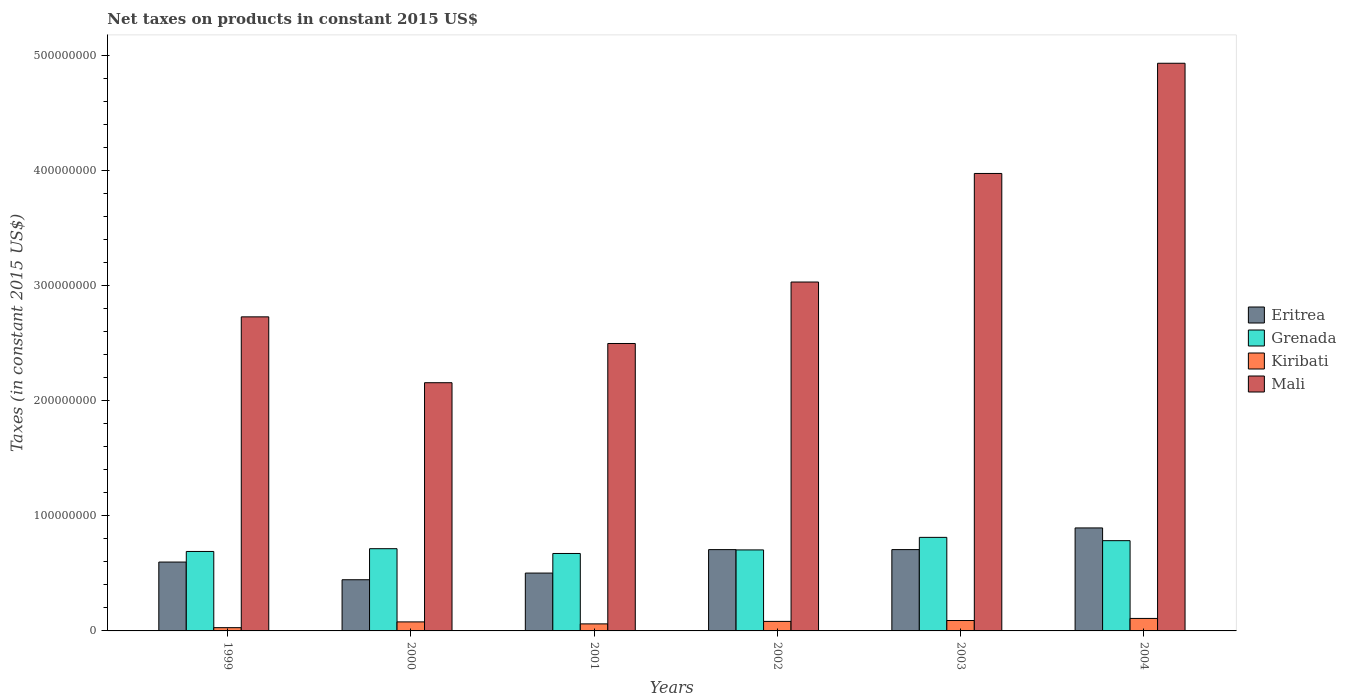How many groups of bars are there?
Provide a short and direct response. 6. How many bars are there on the 4th tick from the left?
Provide a succinct answer. 4. In how many cases, is the number of bars for a given year not equal to the number of legend labels?
Offer a very short reply. 0. What is the net taxes on products in Eritrea in 1999?
Offer a very short reply. 5.98e+07. Across all years, what is the maximum net taxes on products in Grenada?
Provide a short and direct response. 8.12e+07. Across all years, what is the minimum net taxes on products in Grenada?
Keep it short and to the point. 6.73e+07. In which year was the net taxes on products in Eritrea maximum?
Ensure brevity in your answer.  2004. What is the total net taxes on products in Grenada in the graph?
Keep it short and to the point. 4.38e+08. What is the difference between the net taxes on products in Mali in 2000 and that in 2003?
Ensure brevity in your answer.  -1.82e+08. What is the difference between the net taxes on products in Grenada in 2003 and the net taxes on products in Mali in 1999?
Provide a succinct answer. -1.91e+08. What is the average net taxes on products in Mali per year?
Keep it short and to the point. 3.22e+08. In the year 2000, what is the difference between the net taxes on products in Kiribati and net taxes on products in Mali?
Offer a very short reply. -2.08e+08. In how many years, is the net taxes on products in Mali greater than 100000000 US$?
Make the answer very short. 6. What is the ratio of the net taxes on products in Grenada in 2002 to that in 2003?
Your answer should be compact. 0.87. Is the difference between the net taxes on products in Kiribati in 2000 and 2004 greater than the difference between the net taxes on products in Mali in 2000 and 2004?
Your response must be concise. Yes. What is the difference between the highest and the second highest net taxes on products in Eritrea?
Offer a very short reply. 1.88e+07. What is the difference between the highest and the lowest net taxes on products in Eritrea?
Keep it short and to the point. 4.50e+07. Is it the case that in every year, the sum of the net taxes on products in Kiribati and net taxes on products in Mali is greater than the sum of net taxes on products in Grenada and net taxes on products in Eritrea?
Make the answer very short. No. What does the 1st bar from the left in 2001 represents?
Keep it short and to the point. Eritrea. What does the 1st bar from the right in 2001 represents?
Ensure brevity in your answer.  Mali. How many bars are there?
Make the answer very short. 24. Are all the bars in the graph horizontal?
Offer a terse response. No. How many years are there in the graph?
Your answer should be very brief. 6. Where does the legend appear in the graph?
Your response must be concise. Center right. What is the title of the graph?
Keep it short and to the point. Net taxes on products in constant 2015 US$. What is the label or title of the X-axis?
Keep it short and to the point. Years. What is the label or title of the Y-axis?
Give a very brief answer. Taxes (in constant 2015 US$). What is the Taxes (in constant 2015 US$) in Eritrea in 1999?
Ensure brevity in your answer.  5.98e+07. What is the Taxes (in constant 2015 US$) in Grenada in 1999?
Keep it short and to the point. 6.90e+07. What is the Taxes (in constant 2015 US$) in Kiribati in 1999?
Offer a terse response. 2.83e+06. What is the Taxes (in constant 2015 US$) in Mali in 1999?
Your answer should be compact. 2.73e+08. What is the Taxes (in constant 2015 US$) in Eritrea in 2000?
Ensure brevity in your answer.  4.44e+07. What is the Taxes (in constant 2015 US$) in Grenada in 2000?
Make the answer very short. 7.14e+07. What is the Taxes (in constant 2015 US$) in Kiribati in 2000?
Your answer should be very brief. 7.83e+06. What is the Taxes (in constant 2015 US$) in Mali in 2000?
Your answer should be very brief. 2.16e+08. What is the Taxes (in constant 2015 US$) of Eritrea in 2001?
Offer a very short reply. 5.02e+07. What is the Taxes (in constant 2015 US$) of Grenada in 2001?
Make the answer very short. 6.73e+07. What is the Taxes (in constant 2015 US$) in Kiribati in 2001?
Ensure brevity in your answer.  6.11e+06. What is the Taxes (in constant 2015 US$) in Mali in 2001?
Give a very brief answer. 2.50e+08. What is the Taxes (in constant 2015 US$) in Eritrea in 2002?
Your answer should be very brief. 7.06e+07. What is the Taxes (in constant 2015 US$) in Grenada in 2002?
Your answer should be very brief. 7.03e+07. What is the Taxes (in constant 2015 US$) in Kiribati in 2002?
Give a very brief answer. 8.26e+06. What is the Taxes (in constant 2015 US$) of Mali in 2002?
Your answer should be compact. 3.03e+08. What is the Taxes (in constant 2015 US$) of Eritrea in 2003?
Your response must be concise. 7.06e+07. What is the Taxes (in constant 2015 US$) in Grenada in 2003?
Give a very brief answer. 8.12e+07. What is the Taxes (in constant 2015 US$) in Kiribati in 2003?
Provide a short and direct response. 9.03e+06. What is the Taxes (in constant 2015 US$) of Mali in 2003?
Ensure brevity in your answer.  3.97e+08. What is the Taxes (in constant 2015 US$) of Eritrea in 2004?
Offer a terse response. 8.94e+07. What is the Taxes (in constant 2015 US$) of Grenada in 2004?
Offer a terse response. 7.84e+07. What is the Taxes (in constant 2015 US$) of Kiribati in 2004?
Provide a short and direct response. 1.08e+07. What is the Taxes (in constant 2015 US$) of Mali in 2004?
Give a very brief answer. 4.93e+08. Across all years, what is the maximum Taxes (in constant 2015 US$) of Eritrea?
Provide a succinct answer. 8.94e+07. Across all years, what is the maximum Taxes (in constant 2015 US$) in Grenada?
Ensure brevity in your answer.  8.12e+07. Across all years, what is the maximum Taxes (in constant 2015 US$) in Kiribati?
Your response must be concise. 1.08e+07. Across all years, what is the maximum Taxes (in constant 2015 US$) in Mali?
Your answer should be very brief. 4.93e+08. Across all years, what is the minimum Taxes (in constant 2015 US$) of Eritrea?
Offer a terse response. 4.44e+07. Across all years, what is the minimum Taxes (in constant 2015 US$) of Grenada?
Your answer should be very brief. 6.73e+07. Across all years, what is the minimum Taxes (in constant 2015 US$) in Kiribati?
Your answer should be very brief. 2.83e+06. Across all years, what is the minimum Taxes (in constant 2015 US$) of Mali?
Give a very brief answer. 2.16e+08. What is the total Taxes (in constant 2015 US$) of Eritrea in the graph?
Your answer should be very brief. 3.85e+08. What is the total Taxes (in constant 2015 US$) of Grenada in the graph?
Offer a very short reply. 4.38e+08. What is the total Taxes (in constant 2015 US$) in Kiribati in the graph?
Ensure brevity in your answer.  4.49e+07. What is the total Taxes (in constant 2015 US$) in Mali in the graph?
Your answer should be compact. 1.93e+09. What is the difference between the Taxes (in constant 2015 US$) in Eritrea in 1999 and that in 2000?
Provide a short and direct response. 1.54e+07. What is the difference between the Taxes (in constant 2015 US$) in Grenada in 1999 and that in 2000?
Your answer should be compact. -2.40e+06. What is the difference between the Taxes (in constant 2015 US$) in Kiribati in 1999 and that in 2000?
Your answer should be compact. -5.00e+06. What is the difference between the Taxes (in constant 2015 US$) of Mali in 1999 and that in 2000?
Your answer should be compact. 5.72e+07. What is the difference between the Taxes (in constant 2015 US$) in Eritrea in 1999 and that in 2001?
Offer a terse response. 9.56e+06. What is the difference between the Taxes (in constant 2015 US$) of Grenada in 1999 and that in 2001?
Your answer should be compact. 1.75e+06. What is the difference between the Taxes (in constant 2015 US$) in Kiribati in 1999 and that in 2001?
Keep it short and to the point. -3.28e+06. What is the difference between the Taxes (in constant 2015 US$) of Mali in 1999 and that in 2001?
Your answer should be compact. 2.31e+07. What is the difference between the Taxes (in constant 2015 US$) of Eritrea in 1999 and that in 2002?
Give a very brief answer. -1.08e+07. What is the difference between the Taxes (in constant 2015 US$) in Grenada in 1999 and that in 2002?
Your answer should be very brief. -1.34e+06. What is the difference between the Taxes (in constant 2015 US$) of Kiribati in 1999 and that in 2002?
Provide a short and direct response. -5.44e+06. What is the difference between the Taxes (in constant 2015 US$) of Mali in 1999 and that in 2002?
Provide a short and direct response. -3.03e+07. What is the difference between the Taxes (in constant 2015 US$) of Eritrea in 1999 and that in 2003?
Your response must be concise. -1.08e+07. What is the difference between the Taxes (in constant 2015 US$) of Grenada in 1999 and that in 2003?
Provide a short and direct response. -1.22e+07. What is the difference between the Taxes (in constant 2015 US$) of Kiribati in 1999 and that in 2003?
Offer a very short reply. -6.21e+06. What is the difference between the Taxes (in constant 2015 US$) of Mali in 1999 and that in 2003?
Your answer should be very brief. -1.25e+08. What is the difference between the Taxes (in constant 2015 US$) in Eritrea in 1999 and that in 2004?
Your response must be concise. -2.96e+07. What is the difference between the Taxes (in constant 2015 US$) of Grenada in 1999 and that in 2004?
Provide a succinct answer. -9.37e+06. What is the difference between the Taxes (in constant 2015 US$) of Kiribati in 1999 and that in 2004?
Your response must be concise. -8.02e+06. What is the difference between the Taxes (in constant 2015 US$) in Mali in 1999 and that in 2004?
Your answer should be compact. -2.20e+08. What is the difference between the Taxes (in constant 2015 US$) of Eritrea in 2000 and that in 2001?
Offer a very short reply. -5.80e+06. What is the difference between the Taxes (in constant 2015 US$) in Grenada in 2000 and that in 2001?
Ensure brevity in your answer.  4.15e+06. What is the difference between the Taxes (in constant 2015 US$) in Kiribati in 2000 and that in 2001?
Provide a short and direct response. 1.73e+06. What is the difference between the Taxes (in constant 2015 US$) in Mali in 2000 and that in 2001?
Offer a terse response. -3.41e+07. What is the difference between the Taxes (in constant 2015 US$) of Eritrea in 2000 and that in 2002?
Keep it short and to the point. -2.62e+07. What is the difference between the Taxes (in constant 2015 US$) in Grenada in 2000 and that in 2002?
Provide a succinct answer. 1.06e+06. What is the difference between the Taxes (in constant 2015 US$) of Kiribati in 2000 and that in 2002?
Your answer should be very brief. -4.34e+05. What is the difference between the Taxes (in constant 2015 US$) in Mali in 2000 and that in 2002?
Offer a very short reply. -8.74e+07. What is the difference between the Taxes (in constant 2015 US$) in Eritrea in 2000 and that in 2003?
Make the answer very short. -2.62e+07. What is the difference between the Taxes (in constant 2015 US$) of Grenada in 2000 and that in 2003?
Make the answer very short. -9.83e+06. What is the difference between the Taxes (in constant 2015 US$) of Kiribati in 2000 and that in 2003?
Provide a succinct answer. -1.20e+06. What is the difference between the Taxes (in constant 2015 US$) in Mali in 2000 and that in 2003?
Keep it short and to the point. -1.82e+08. What is the difference between the Taxes (in constant 2015 US$) in Eritrea in 2000 and that in 2004?
Provide a succinct answer. -4.50e+07. What is the difference between the Taxes (in constant 2015 US$) in Grenada in 2000 and that in 2004?
Your answer should be very brief. -6.97e+06. What is the difference between the Taxes (in constant 2015 US$) in Kiribati in 2000 and that in 2004?
Provide a succinct answer. -3.01e+06. What is the difference between the Taxes (in constant 2015 US$) in Mali in 2000 and that in 2004?
Offer a terse response. -2.77e+08. What is the difference between the Taxes (in constant 2015 US$) in Eritrea in 2001 and that in 2002?
Offer a terse response. -2.04e+07. What is the difference between the Taxes (in constant 2015 US$) of Grenada in 2001 and that in 2002?
Your response must be concise. -3.10e+06. What is the difference between the Taxes (in constant 2015 US$) of Kiribati in 2001 and that in 2002?
Give a very brief answer. -2.16e+06. What is the difference between the Taxes (in constant 2015 US$) in Mali in 2001 and that in 2002?
Your response must be concise. -5.34e+07. What is the difference between the Taxes (in constant 2015 US$) of Eritrea in 2001 and that in 2003?
Ensure brevity in your answer.  -2.04e+07. What is the difference between the Taxes (in constant 2015 US$) of Grenada in 2001 and that in 2003?
Keep it short and to the point. -1.40e+07. What is the difference between the Taxes (in constant 2015 US$) of Kiribati in 2001 and that in 2003?
Your response must be concise. -2.93e+06. What is the difference between the Taxes (in constant 2015 US$) in Mali in 2001 and that in 2003?
Make the answer very short. -1.48e+08. What is the difference between the Taxes (in constant 2015 US$) in Eritrea in 2001 and that in 2004?
Your response must be concise. -3.92e+07. What is the difference between the Taxes (in constant 2015 US$) of Grenada in 2001 and that in 2004?
Make the answer very short. -1.11e+07. What is the difference between the Taxes (in constant 2015 US$) of Kiribati in 2001 and that in 2004?
Provide a short and direct response. -4.74e+06. What is the difference between the Taxes (in constant 2015 US$) in Mali in 2001 and that in 2004?
Provide a succinct answer. -2.43e+08. What is the difference between the Taxes (in constant 2015 US$) in Eritrea in 2002 and that in 2003?
Keep it short and to the point. -1.22e+04. What is the difference between the Taxes (in constant 2015 US$) of Grenada in 2002 and that in 2003?
Your answer should be very brief. -1.09e+07. What is the difference between the Taxes (in constant 2015 US$) in Kiribati in 2002 and that in 2003?
Ensure brevity in your answer.  -7.69e+05. What is the difference between the Taxes (in constant 2015 US$) of Mali in 2002 and that in 2003?
Your response must be concise. -9.43e+07. What is the difference between the Taxes (in constant 2015 US$) of Eritrea in 2002 and that in 2004?
Provide a succinct answer. -1.88e+07. What is the difference between the Taxes (in constant 2015 US$) in Grenada in 2002 and that in 2004?
Offer a terse response. -8.02e+06. What is the difference between the Taxes (in constant 2015 US$) of Kiribati in 2002 and that in 2004?
Your response must be concise. -2.58e+06. What is the difference between the Taxes (in constant 2015 US$) in Mali in 2002 and that in 2004?
Your response must be concise. -1.90e+08. What is the difference between the Taxes (in constant 2015 US$) in Eritrea in 2003 and that in 2004?
Your answer should be very brief. -1.88e+07. What is the difference between the Taxes (in constant 2015 US$) in Grenada in 2003 and that in 2004?
Offer a terse response. 2.86e+06. What is the difference between the Taxes (in constant 2015 US$) of Kiribati in 2003 and that in 2004?
Your answer should be compact. -1.81e+06. What is the difference between the Taxes (in constant 2015 US$) of Mali in 2003 and that in 2004?
Give a very brief answer. -9.57e+07. What is the difference between the Taxes (in constant 2015 US$) of Eritrea in 1999 and the Taxes (in constant 2015 US$) of Grenada in 2000?
Make the answer very short. -1.16e+07. What is the difference between the Taxes (in constant 2015 US$) in Eritrea in 1999 and the Taxes (in constant 2015 US$) in Kiribati in 2000?
Your response must be concise. 5.20e+07. What is the difference between the Taxes (in constant 2015 US$) in Eritrea in 1999 and the Taxes (in constant 2015 US$) in Mali in 2000?
Keep it short and to the point. -1.56e+08. What is the difference between the Taxes (in constant 2015 US$) in Grenada in 1999 and the Taxes (in constant 2015 US$) in Kiribati in 2000?
Give a very brief answer. 6.12e+07. What is the difference between the Taxes (in constant 2015 US$) of Grenada in 1999 and the Taxes (in constant 2015 US$) of Mali in 2000?
Your response must be concise. -1.47e+08. What is the difference between the Taxes (in constant 2015 US$) of Kiribati in 1999 and the Taxes (in constant 2015 US$) of Mali in 2000?
Your answer should be compact. -2.13e+08. What is the difference between the Taxes (in constant 2015 US$) in Eritrea in 1999 and the Taxes (in constant 2015 US$) in Grenada in 2001?
Offer a terse response. -7.45e+06. What is the difference between the Taxes (in constant 2015 US$) in Eritrea in 1999 and the Taxes (in constant 2015 US$) in Kiribati in 2001?
Ensure brevity in your answer.  5.37e+07. What is the difference between the Taxes (in constant 2015 US$) in Eritrea in 1999 and the Taxes (in constant 2015 US$) in Mali in 2001?
Your response must be concise. -1.90e+08. What is the difference between the Taxes (in constant 2015 US$) in Grenada in 1999 and the Taxes (in constant 2015 US$) in Kiribati in 2001?
Your answer should be very brief. 6.29e+07. What is the difference between the Taxes (in constant 2015 US$) in Grenada in 1999 and the Taxes (in constant 2015 US$) in Mali in 2001?
Your answer should be very brief. -1.81e+08. What is the difference between the Taxes (in constant 2015 US$) of Kiribati in 1999 and the Taxes (in constant 2015 US$) of Mali in 2001?
Keep it short and to the point. -2.47e+08. What is the difference between the Taxes (in constant 2015 US$) in Eritrea in 1999 and the Taxes (in constant 2015 US$) in Grenada in 2002?
Make the answer very short. -1.06e+07. What is the difference between the Taxes (in constant 2015 US$) of Eritrea in 1999 and the Taxes (in constant 2015 US$) of Kiribati in 2002?
Give a very brief answer. 5.15e+07. What is the difference between the Taxes (in constant 2015 US$) in Eritrea in 1999 and the Taxes (in constant 2015 US$) in Mali in 2002?
Offer a terse response. -2.43e+08. What is the difference between the Taxes (in constant 2015 US$) in Grenada in 1999 and the Taxes (in constant 2015 US$) in Kiribati in 2002?
Your answer should be compact. 6.07e+07. What is the difference between the Taxes (in constant 2015 US$) in Grenada in 1999 and the Taxes (in constant 2015 US$) in Mali in 2002?
Make the answer very short. -2.34e+08. What is the difference between the Taxes (in constant 2015 US$) in Kiribati in 1999 and the Taxes (in constant 2015 US$) in Mali in 2002?
Provide a short and direct response. -3.00e+08. What is the difference between the Taxes (in constant 2015 US$) of Eritrea in 1999 and the Taxes (in constant 2015 US$) of Grenada in 2003?
Your answer should be very brief. -2.14e+07. What is the difference between the Taxes (in constant 2015 US$) in Eritrea in 1999 and the Taxes (in constant 2015 US$) in Kiribati in 2003?
Keep it short and to the point. 5.08e+07. What is the difference between the Taxes (in constant 2015 US$) in Eritrea in 1999 and the Taxes (in constant 2015 US$) in Mali in 2003?
Keep it short and to the point. -3.37e+08. What is the difference between the Taxes (in constant 2015 US$) in Grenada in 1999 and the Taxes (in constant 2015 US$) in Kiribati in 2003?
Make the answer very short. 6.00e+07. What is the difference between the Taxes (in constant 2015 US$) in Grenada in 1999 and the Taxes (in constant 2015 US$) in Mali in 2003?
Offer a terse response. -3.28e+08. What is the difference between the Taxes (in constant 2015 US$) in Kiribati in 1999 and the Taxes (in constant 2015 US$) in Mali in 2003?
Keep it short and to the point. -3.94e+08. What is the difference between the Taxes (in constant 2015 US$) in Eritrea in 1999 and the Taxes (in constant 2015 US$) in Grenada in 2004?
Provide a succinct answer. -1.86e+07. What is the difference between the Taxes (in constant 2015 US$) in Eritrea in 1999 and the Taxes (in constant 2015 US$) in Kiribati in 2004?
Provide a short and direct response. 4.90e+07. What is the difference between the Taxes (in constant 2015 US$) in Eritrea in 1999 and the Taxes (in constant 2015 US$) in Mali in 2004?
Give a very brief answer. -4.33e+08. What is the difference between the Taxes (in constant 2015 US$) in Grenada in 1999 and the Taxes (in constant 2015 US$) in Kiribati in 2004?
Keep it short and to the point. 5.82e+07. What is the difference between the Taxes (in constant 2015 US$) of Grenada in 1999 and the Taxes (in constant 2015 US$) of Mali in 2004?
Make the answer very short. -4.24e+08. What is the difference between the Taxes (in constant 2015 US$) in Kiribati in 1999 and the Taxes (in constant 2015 US$) in Mali in 2004?
Provide a short and direct response. -4.90e+08. What is the difference between the Taxes (in constant 2015 US$) of Eritrea in 2000 and the Taxes (in constant 2015 US$) of Grenada in 2001?
Make the answer very short. -2.28e+07. What is the difference between the Taxes (in constant 2015 US$) in Eritrea in 2000 and the Taxes (in constant 2015 US$) in Kiribati in 2001?
Provide a succinct answer. 3.83e+07. What is the difference between the Taxes (in constant 2015 US$) of Eritrea in 2000 and the Taxes (in constant 2015 US$) of Mali in 2001?
Make the answer very short. -2.05e+08. What is the difference between the Taxes (in constant 2015 US$) of Grenada in 2000 and the Taxes (in constant 2015 US$) of Kiribati in 2001?
Offer a terse response. 6.53e+07. What is the difference between the Taxes (in constant 2015 US$) of Grenada in 2000 and the Taxes (in constant 2015 US$) of Mali in 2001?
Offer a very short reply. -1.78e+08. What is the difference between the Taxes (in constant 2015 US$) of Kiribati in 2000 and the Taxes (in constant 2015 US$) of Mali in 2001?
Your answer should be very brief. -2.42e+08. What is the difference between the Taxes (in constant 2015 US$) of Eritrea in 2000 and the Taxes (in constant 2015 US$) of Grenada in 2002?
Your response must be concise. -2.59e+07. What is the difference between the Taxes (in constant 2015 US$) in Eritrea in 2000 and the Taxes (in constant 2015 US$) in Kiribati in 2002?
Ensure brevity in your answer.  3.62e+07. What is the difference between the Taxes (in constant 2015 US$) of Eritrea in 2000 and the Taxes (in constant 2015 US$) of Mali in 2002?
Your answer should be very brief. -2.59e+08. What is the difference between the Taxes (in constant 2015 US$) in Grenada in 2000 and the Taxes (in constant 2015 US$) in Kiribati in 2002?
Ensure brevity in your answer.  6.31e+07. What is the difference between the Taxes (in constant 2015 US$) in Grenada in 2000 and the Taxes (in constant 2015 US$) in Mali in 2002?
Provide a succinct answer. -2.32e+08. What is the difference between the Taxes (in constant 2015 US$) in Kiribati in 2000 and the Taxes (in constant 2015 US$) in Mali in 2002?
Provide a short and direct response. -2.95e+08. What is the difference between the Taxes (in constant 2015 US$) in Eritrea in 2000 and the Taxes (in constant 2015 US$) in Grenada in 2003?
Your answer should be compact. -3.68e+07. What is the difference between the Taxes (in constant 2015 US$) in Eritrea in 2000 and the Taxes (in constant 2015 US$) in Kiribati in 2003?
Provide a succinct answer. 3.54e+07. What is the difference between the Taxes (in constant 2015 US$) in Eritrea in 2000 and the Taxes (in constant 2015 US$) in Mali in 2003?
Offer a terse response. -3.53e+08. What is the difference between the Taxes (in constant 2015 US$) of Grenada in 2000 and the Taxes (in constant 2015 US$) of Kiribati in 2003?
Offer a terse response. 6.24e+07. What is the difference between the Taxes (in constant 2015 US$) in Grenada in 2000 and the Taxes (in constant 2015 US$) in Mali in 2003?
Your answer should be very brief. -3.26e+08. What is the difference between the Taxes (in constant 2015 US$) of Kiribati in 2000 and the Taxes (in constant 2015 US$) of Mali in 2003?
Your answer should be compact. -3.89e+08. What is the difference between the Taxes (in constant 2015 US$) in Eritrea in 2000 and the Taxes (in constant 2015 US$) in Grenada in 2004?
Offer a terse response. -3.39e+07. What is the difference between the Taxes (in constant 2015 US$) of Eritrea in 2000 and the Taxes (in constant 2015 US$) of Kiribati in 2004?
Keep it short and to the point. 3.36e+07. What is the difference between the Taxes (in constant 2015 US$) in Eritrea in 2000 and the Taxes (in constant 2015 US$) in Mali in 2004?
Offer a very short reply. -4.48e+08. What is the difference between the Taxes (in constant 2015 US$) in Grenada in 2000 and the Taxes (in constant 2015 US$) in Kiribati in 2004?
Your answer should be very brief. 6.06e+07. What is the difference between the Taxes (in constant 2015 US$) of Grenada in 2000 and the Taxes (in constant 2015 US$) of Mali in 2004?
Your response must be concise. -4.22e+08. What is the difference between the Taxes (in constant 2015 US$) of Kiribati in 2000 and the Taxes (in constant 2015 US$) of Mali in 2004?
Provide a succinct answer. -4.85e+08. What is the difference between the Taxes (in constant 2015 US$) in Eritrea in 2001 and the Taxes (in constant 2015 US$) in Grenada in 2002?
Your answer should be very brief. -2.01e+07. What is the difference between the Taxes (in constant 2015 US$) of Eritrea in 2001 and the Taxes (in constant 2015 US$) of Kiribati in 2002?
Keep it short and to the point. 4.20e+07. What is the difference between the Taxes (in constant 2015 US$) in Eritrea in 2001 and the Taxes (in constant 2015 US$) in Mali in 2002?
Make the answer very short. -2.53e+08. What is the difference between the Taxes (in constant 2015 US$) of Grenada in 2001 and the Taxes (in constant 2015 US$) of Kiribati in 2002?
Provide a succinct answer. 5.90e+07. What is the difference between the Taxes (in constant 2015 US$) in Grenada in 2001 and the Taxes (in constant 2015 US$) in Mali in 2002?
Offer a terse response. -2.36e+08. What is the difference between the Taxes (in constant 2015 US$) of Kiribati in 2001 and the Taxes (in constant 2015 US$) of Mali in 2002?
Your answer should be very brief. -2.97e+08. What is the difference between the Taxes (in constant 2015 US$) in Eritrea in 2001 and the Taxes (in constant 2015 US$) in Grenada in 2003?
Your response must be concise. -3.10e+07. What is the difference between the Taxes (in constant 2015 US$) in Eritrea in 2001 and the Taxes (in constant 2015 US$) in Kiribati in 2003?
Provide a short and direct response. 4.12e+07. What is the difference between the Taxes (in constant 2015 US$) in Eritrea in 2001 and the Taxes (in constant 2015 US$) in Mali in 2003?
Make the answer very short. -3.47e+08. What is the difference between the Taxes (in constant 2015 US$) of Grenada in 2001 and the Taxes (in constant 2015 US$) of Kiribati in 2003?
Offer a terse response. 5.82e+07. What is the difference between the Taxes (in constant 2015 US$) of Grenada in 2001 and the Taxes (in constant 2015 US$) of Mali in 2003?
Offer a terse response. -3.30e+08. What is the difference between the Taxes (in constant 2015 US$) of Kiribati in 2001 and the Taxes (in constant 2015 US$) of Mali in 2003?
Provide a succinct answer. -3.91e+08. What is the difference between the Taxes (in constant 2015 US$) in Eritrea in 2001 and the Taxes (in constant 2015 US$) in Grenada in 2004?
Your answer should be very brief. -2.81e+07. What is the difference between the Taxes (in constant 2015 US$) in Eritrea in 2001 and the Taxes (in constant 2015 US$) in Kiribati in 2004?
Provide a short and direct response. 3.94e+07. What is the difference between the Taxes (in constant 2015 US$) of Eritrea in 2001 and the Taxes (in constant 2015 US$) of Mali in 2004?
Offer a very short reply. -4.43e+08. What is the difference between the Taxes (in constant 2015 US$) in Grenada in 2001 and the Taxes (in constant 2015 US$) in Kiribati in 2004?
Provide a succinct answer. 5.64e+07. What is the difference between the Taxes (in constant 2015 US$) in Grenada in 2001 and the Taxes (in constant 2015 US$) in Mali in 2004?
Provide a short and direct response. -4.26e+08. What is the difference between the Taxes (in constant 2015 US$) of Kiribati in 2001 and the Taxes (in constant 2015 US$) of Mali in 2004?
Keep it short and to the point. -4.87e+08. What is the difference between the Taxes (in constant 2015 US$) of Eritrea in 2002 and the Taxes (in constant 2015 US$) of Grenada in 2003?
Your response must be concise. -1.06e+07. What is the difference between the Taxes (in constant 2015 US$) of Eritrea in 2002 and the Taxes (in constant 2015 US$) of Kiribati in 2003?
Offer a very short reply. 6.16e+07. What is the difference between the Taxes (in constant 2015 US$) of Eritrea in 2002 and the Taxes (in constant 2015 US$) of Mali in 2003?
Your answer should be compact. -3.27e+08. What is the difference between the Taxes (in constant 2015 US$) in Grenada in 2002 and the Taxes (in constant 2015 US$) in Kiribati in 2003?
Ensure brevity in your answer.  6.13e+07. What is the difference between the Taxes (in constant 2015 US$) in Grenada in 2002 and the Taxes (in constant 2015 US$) in Mali in 2003?
Your answer should be compact. -3.27e+08. What is the difference between the Taxes (in constant 2015 US$) of Kiribati in 2002 and the Taxes (in constant 2015 US$) of Mali in 2003?
Give a very brief answer. -3.89e+08. What is the difference between the Taxes (in constant 2015 US$) of Eritrea in 2002 and the Taxes (in constant 2015 US$) of Grenada in 2004?
Make the answer very short. -7.77e+06. What is the difference between the Taxes (in constant 2015 US$) of Eritrea in 2002 and the Taxes (in constant 2015 US$) of Kiribati in 2004?
Your answer should be compact. 5.98e+07. What is the difference between the Taxes (in constant 2015 US$) of Eritrea in 2002 and the Taxes (in constant 2015 US$) of Mali in 2004?
Offer a terse response. -4.22e+08. What is the difference between the Taxes (in constant 2015 US$) of Grenada in 2002 and the Taxes (in constant 2015 US$) of Kiribati in 2004?
Provide a short and direct response. 5.95e+07. What is the difference between the Taxes (in constant 2015 US$) in Grenada in 2002 and the Taxes (in constant 2015 US$) in Mali in 2004?
Provide a succinct answer. -4.23e+08. What is the difference between the Taxes (in constant 2015 US$) in Kiribati in 2002 and the Taxes (in constant 2015 US$) in Mali in 2004?
Provide a succinct answer. -4.85e+08. What is the difference between the Taxes (in constant 2015 US$) in Eritrea in 2003 and the Taxes (in constant 2015 US$) in Grenada in 2004?
Your response must be concise. -7.76e+06. What is the difference between the Taxes (in constant 2015 US$) in Eritrea in 2003 and the Taxes (in constant 2015 US$) in Kiribati in 2004?
Offer a terse response. 5.98e+07. What is the difference between the Taxes (in constant 2015 US$) in Eritrea in 2003 and the Taxes (in constant 2015 US$) in Mali in 2004?
Your answer should be compact. -4.22e+08. What is the difference between the Taxes (in constant 2015 US$) of Grenada in 2003 and the Taxes (in constant 2015 US$) of Kiribati in 2004?
Your answer should be compact. 7.04e+07. What is the difference between the Taxes (in constant 2015 US$) in Grenada in 2003 and the Taxes (in constant 2015 US$) in Mali in 2004?
Your answer should be very brief. -4.12e+08. What is the difference between the Taxes (in constant 2015 US$) in Kiribati in 2003 and the Taxes (in constant 2015 US$) in Mali in 2004?
Ensure brevity in your answer.  -4.84e+08. What is the average Taxes (in constant 2015 US$) in Eritrea per year?
Make the answer very short. 6.42e+07. What is the average Taxes (in constant 2015 US$) of Grenada per year?
Provide a succinct answer. 7.29e+07. What is the average Taxes (in constant 2015 US$) in Kiribati per year?
Make the answer very short. 7.48e+06. What is the average Taxes (in constant 2015 US$) of Mali per year?
Provide a short and direct response. 3.22e+08. In the year 1999, what is the difference between the Taxes (in constant 2015 US$) in Eritrea and Taxes (in constant 2015 US$) in Grenada?
Make the answer very short. -9.21e+06. In the year 1999, what is the difference between the Taxes (in constant 2015 US$) in Eritrea and Taxes (in constant 2015 US$) in Kiribati?
Your answer should be very brief. 5.70e+07. In the year 1999, what is the difference between the Taxes (in constant 2015 US$) in Eritrea and Taxes (in constant 2015 US$) in Mali?
Provide a succinct answer. -2.13e+08. In the year 1999, what is the difference between the Taxes (in constant 2015 US$) in Grenada and Taxes (in constant 2015 US$) in Kiribati?
Ensure brevity in your answer.  6.62e+07. In the year 1999, what is the difference between the Taxes (in constant 2015 US$) of Grenada and Taxes (in constant 2015 US$) of Mali?
Ensure brevity in your answer.  -2.04e+08. In the year 1999, what is the difference between the Taxes (in constant 2015 US$) in Kiribati and Taxes (in constant 2015 US$) in Mali?
Provide a succinct answer. -2.70e+08. In the year 2000, what is the difference between the Taxes (in constant 2015 US$) of Eritrea and Taxes (in constant 2015 US$) of Grenada?
Keep it short and to the point. -2.70e+07. In the year 2000, what is the difference between the Taxes (in constant 2015 US$) of Eritrea and Taxes (in constant 2015 US$) of Kiribati?
Make the answer very short. 3.66e+07. In the year 2000, what is the difference between the Taxes (in constant 2015 US$) in Eritrea and Taxes (in constant 2015 US$) in Mali?
Make the answer very short. -1.71e+08. In the year 2000, what is the difference between the Taxes (in constant 2015 US$) of Grenada and Taxes (in constant 2015 US$) of Kiribati?
Make the answer very short. 6.36e+07. In the year 2000, what is the difference between the Taxes (in constant 2015 US$) of Grenada and Taxes (in constant 2015 US$) of Mali?
Your response must be concise. -1.44e+08. In the year 2000, what is the difference between the Taxes (in constant 2015 US$) of Kiribati and Taxes (in constant 2015 US$) of Mali?
Your response must be concise. -2.08e+08. In the year 2001, what is the difference between the Taxes (in constant 2015 US$) of Eritrea and Taxes (in constant 2015 US$) of Grenada?
Provide a short and direct response. -1.70e+07. In the year 2001, what is the difference between the Taxes (in constant 2015 US$) of Eritrea and Taxes (in constant 2015 US$) of Kiribati?
Offer a terse response. 4.41e+07. In the year 2001, what is the difference between the Taxes (in constant 2015 US$) of Eritrea and Taxes (in constant 2015 US$) of Mali?
Make the answer very short. -1.99e+08. In the year 2001, what is the difference between the Taxes (in constant 2015 US$) in Grenada and Taxes (in constant 2015 US$) in Kiribati?
Provide a succinct answer. 6.11e+07. In the year 2001, what is the difference between the Taxes (in constant 2015 US$) in Grenada and Taxes (in constant 2015 US$) in Mali?
Offer a terse response. -1.82e+08. In the year 2001, what is the difference between the Taxes (in constant 2015 US$) of Kiribati and Taxes (in constant 2015 US$) of Mali?
Offer a very short reply. -2.43e+08. In the year 2002, what is the difference between the Taxes (in constant 2015 US$) of Eritrea and Taxes (in constant 2015 US$) of Grenada?
Provide a short and direct response. 2.48e+05. In the year 2002, what is the difference between the Taxes (in constant 2015 US$) in Eritrea and Taxes (in constant 2015 US$) in Kiribati?
Offer a very short reply. 6.23e+07. In the year 2002, what is the difference between the Taxes (in constant 2015 US$) of Eritrea and Taxes (in constant 2015 US$) of Mali?
Offer a terse response. -2.32e+08. In the year 2002, what is the difference between the Taxes (in constant 2015 US$) of Grenada and Taxes (in constant 2015 US$) of Kiribati?
Make the answer very short. 6.21e+07. In the year 2002, what is the difference between the Taxes (in constant 2015 US$) in Grenada and Taxes (in constant 2015 US$) in Mali?
Your answer should be compact. -2.33e+08. In the year 2002, what is the difference between the Taxes (in constant 2015 US$) in Kiribati and Taxes (in constant 2015 US$) in Mali?
Your answer should be very brief. -2.95e+08. In the year 2003, what is the difference between the Taxes (in constant 2015 US$) in Eritrea and Taxes (in constant 2015 US$) in Grenada?
Your answer should be very brief. -1.06e+07. In the year 2003, what is the difference between the Taxes (in constant 2015 US$) of Eritrea and Taxes (in constant 2015 US$) of Kiribati?
Your answer should be compact. 6.16e+07. In the year 2003, what is the difference between the Taxes (in constant 2015 US$) in Eritrea and Taxes (in constant 2015 US$) in Mali?
Your response must be concise. -3.27e+08. In the year 2003, what is the difference between the Taxes (in constant 2015 US$) of Grenada and Taxes (in constant 2015 US$) of Kiribati?
Offer a terse response. 7.22e+07. In the year 2003, what is the difference between the Taxes (in constant 2015 US$) of Grenada and Taxes (in constant 2015 US$) of Mali?
Keep it short and to the point. -3.16e+08. In the year 2003, what is the difference between the Taxes (in constant 2015 US$) in Kiribati and Taxes (in constant 2015 US$) in Mali?
Your answer should be compact. -3.88e+08. In the year 2004, what is the difference between the Taxes (in constant 2015 US$) in Eritrea and Taxes (in constant 2015 US$) in Grenada?
Give a very brief answer. 1.11e+07. In the year 2004, what is the difference between the Taxes (in constant 2015 US$) of Eritrea and Taxes (in constant 2015 US$) of Kiribati?
Offer a terse response. 7.86e+07. In the year 2004, what is the difference between the Taxes (in constant 2015 US$) of Eritrea and Taxes (in constant 2015 US$) of Mali?
Give a very brief answer. -4.03e+08. In the year 2004, what is the difference between the Taxes (in constant 2015 US$) in Grenada and Taxes (in constant 2015 US$) in Kiribati?
Give a very brief answer. 6.75e+07. In the year 2004, what is the difference between the Taxes (in constant 2015 US$) in Grenada and Taxes (in constant 2015 US$) in Mali?
Offer a very short reply. -4.15e+08. In the year 2004, what is the difference between the Taxes (in constant 2015 US$) in Kiribati and Taxes (in constant 2015 US$) in Mali?
Keep it short and to the point. -4.82e+08. What is the ratio of the Taxes (in constant 2015 US$) in Eritrea in 1999 to that in 2000?
Offer a very short reply. 1.35. What is the ratio of the Taxes (in constant 2015 US$) in Grenada in 1999 to that in 2000?
Your response must be concise. 0.97. What is the ratio of the Taxes (in constant 2015 US$) in Kiribati in 1999 to that in 2000?
Ensure brevity in your answer.  0.36. What is the ratio of the Taxes (in constant 2015 US$) of Mali in 1999 to that in 2000?
Offer a terse response. 1.27. What is the ratio of the Taxes (in constant 2015 US$) of Eritrea in 1999 to that in 2001?
Your answer should be very brief. 1.19. What is the ratio of the Taxes (in constant 2015 US$) in Kiribati in 1999 to that in 2001?
Make the answer very short. 0.46. What is the ratio of the Taxes (in constant 2015 US$) in Mali in 1999 to that in 2001?
Keep it short and to the point. 1.09. What is the ratio of the Taxes (in constant 2015 US$) in Eritrea in 1999 to that in 2002?
Your answer should be compact. 0.85. What is the ratio of the Taxes (in constant 2015 US$) of Grenada in 1999 to that in 2002?
Offer a very short reply. 0.98. What is the ratio of the Taxes (in constant 2015 US$) in Kiribati in 1999 to that in 2002?
Make the answer very short. 0.34. What is the ratio of the Taxes (in constant 2015 US$) of Mali in 1999 to that in 2002?
Keep it short and to the point. 0.9. What is the ratio of the Taxes (in constant 2015 US$) in Eritrea in 1999 to that in 2003?
Keep it short and to the point. 0.85. What is the ratio of the Taxes (in constant 2015 US$) of Grenada in 1999 to that in 2003?
Ensure brevity in your answer.  0.85. What is the ratio of the Taxes (in constant 2015 US$) of Kiribati in 1999 to that in 2003?
Ensure brevity in your answer.  0.31. What is the ratio of the Taxes (in constant 2015 US$) in Mali in 1999 to that in 2003?
Offer a very short reply. 0.69. What is the ratio of the Taxes (in constant 2015 US$) in Eritrea in 1999 to that in 2004?
Your answer should be compact. 0.67. What is the ratio of the Taxes (in constant 2015 US$) in Grenada in 1999 to that in 2004?
Your answer should be compact. 0.88. What is the ratio of the Taxes (in constant 2015 US$) in Kiribati in 1999 to that in 2004?
Your answer should be compact. 0.26. What is the ratio of the Taxes (in constant 2015 US$) of Mali in 1999 to that in 2004?
Keep it short and to the point. 0.55. What is the ratio of the Taxes (in constant 2015 US$) in Eritrea in 2000 to that in 2001?
Offer a terse response. 0.88. What is the ratio of the Taxes (in constant 2015 US$) of Grenada in 2000 to that in 2001?
Offer a very short reply. 1.06. What is the ratio of the Taxes (in constant 2015 US$) in Kiribati in 2000 to that in 2001?
Provide a short and direct response. 1.28. What is the ratio of the Taxes (in constant 2015 US$) in Mali in 2000 to that in 2001?
Offer a terse response. 0.86. What is the ratio of the Taxes (in constant 2015 US$) of Eritrea in 2000 to that in 2002?
Give a very brief answer. 0.63. What is the ratio of the Taxes (in constant 2015 US$) of Kiribati in 2000 to that in 2002?
Provide a succinct answer. 0.95. What is the ratio of the Taxes (in constant 2015 US$) of Mali in 2000 to that in 2002?
Ensure brevity in your answer.  0.71. What is the ratio of the Taxes (in constant 2015 US$) in Eritrea in 2000 to that in 2003?
Offer a very short reply. 0.63. What is the ratio of the Taxes (in constant 2015 US$) in Grenada in 2000 to that in 2003?
Your response must be concise. 0.88. What is the ratio of the Taxes (in constant 2015 US$) in Kiribati in 2000 to that in 2003?
Give a very brief answer. 0.87. What is the ratio of the Taxes (in constant 2015 US$) in Mali in 2000 to that in 2003?
Give a very brief answer. 0.54. What is the ratio of the Taxes (in constant 2015 US$) in Eritrea in 2000 to that in 2004?
Your response must be concise. 0.5. What is the ratio of the Taxes (in constant 2015 US$) in Grenada in 2000 to that in 2004?
Ensure brevity in your answer.  0.91. What is the ratio of the Taxes (in constant 2015 US$) in Kiribati in 2000 to that in 2004?
Your answer should be compact. 0.72. What is the ratio of the Taxes (in constant 2015 US$) of Mali in 2000 to that in 2004?
Keep it short and to the point. 0.44. What is the ratio of the Taxes (in constant 2015 US$) in Eritrea in 2001 to that in 2002?
Your answer should be compact. 0.71. What is the ratio of the Taxes (in constant 2015 US$) in Grenada in 2001 to that in 2002?
Your response must be concise. 0.96. What is the ratio of the Taxes (in constant 2015 US$) in Kiribati in 2001 to that in 2002?
Provide a succinct answer. 0.74. What is the ratio of the Taxes (in constant 2015 US$) in Mali in 2001 to that in 2002?
Provide a short and direct response. 0.82. What is the ratio of the Taxes (in constant 2015 US$) of Eritrea in 2001 to that in 2003?
Give a very brief answer. 0.71. What is the ratio of the Taxes (in constant 2015 US$) in Grenada in 2001 to that in 2003?
Offer a terse response. 0.83. What is the ratio of the Taxes (in constant 2015 US$) of Kiribati in 2001 to that in 2003?
Ensure brevity in your answer.  0.68. What is the ratio of the Taxes (in constant 2015 US$) of Mali in 2001 to that in 2003?
Offer a very short reply. 0.63. What is the ratio of the Taxes (in constant 2015 US$) of Eritrea in 2001 to that in 2004?
Offer a terse response. 0.56. What is the ratio of the Taxes (in constant 2015 US$) in Grenada in 2001 to that in 2004?
Make the answer very short. 0.86. What is the ratio of the Taxes (in constant 2015 US$) of Kiribati in 2001 to that in 2004?
Offer a very short reply. 0.56. What is the ratio of the Taxes (in constant 2015 US$) in Mali in 2001 to that in 2004?
Offer a terse response. 0.51. What is the ratio of the Taxes (in constant 2015 US$) in Eritrea in 2002 to that in 2003?
Give a very brief answer. 1. What is the ratio of the Taxes (in constant 2015 US$) of Grenada in 2002 to that in 2003?
Offer a very short reply. 0.87. What is the ratio of the Taxes (in constant 2015 US$) in Kiribati in 2002 to that in 2003?
Make the answer very short. 0.91. What is the ratio of the Taxes (in constant 2015 US$) of Mali in 2002 to that in 2003?
Make the answer very short. 0.76. What is the ratio of the Taxes (in constant 2015 US$) of Eritrea in 2002 to that in 2004?
Offer a terse response. 0.79. What is the ratio of the Taxes (in constant 2015 US$) of Grenada in 2002 to that in 2004?
Your response must be concise. 0.9. What is the ratio of the Taxes (in constant 2015 US$) in Kiribati in 2002 to that in 2004?
Provide a succinct answer. 0.76. What is the ratio of the Taxes (in constant 2015 US$) of Mali in 2002 to that in 2004?
Keep it short and to the point. 0.61. What is the ratio of the Taxes (in constant 2015 US$) of Eritrea in 2003 to that in 2004?
Give a very brief answer. 0.79. What is the ratio of the Taxes (in constant 2015 US$) in Grenada in 2003 to that in 2004?
Provide a succinct answer. 1.04. What is the ratio of the Taxes (in constant 2015 US$) of Kiribati in 2003 to that in 2004?
Offer a very short reply. 0.83. What is the ratio of the Taxes (in constant 2015 US$) of Mali in 2003 to that in 2004?
Offer a terse response. 0.81. What is the difference between the highest and the second highest Taxes (in constant 2015 US$) in Eritrea?
Offer a very short reply. 1.88e+07. What is the difference between the highest and the second highest Taxes (in constant 2015 US$) in Grenada?
Offer a terse response. 2.86e+06. What is the difference between the highest and the second highest Taxes (in constant 2015 US$) of Kiribati?
Your answer should be compact. 1.81e+06. What is the difference between the highest and the second highest Taxes (in constant 2015 US$) in Mali?
Give a very brief answer. 9.57e+07. What is the difference between the highest and the lowest Taxes (in constant 2015 US$) in Eritrea?
Offer a terse response. 4.50e+07. What is the difference between the highest and the lowest Taxes (in constant 2015 US$) in Grenada?
Offer a very short reply. 1.40e+07. What is the difference between the highest and the lowest Taxes (in constant 2015 US$) of Kiribati?
Keep it short and to the point. 8.02e+06. What is the difference between the highest and the lowest Taxes (in constant 2015 US$) of Mali?
Keep it short and to the point. 2.77e+08. 